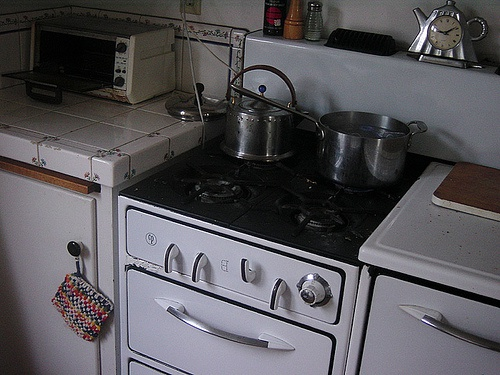Describe the objects in this image and their specific colors. I can see oven in black, darkgray, and gray tones, refrigerator in black and gray tones, microwave in black and gray tones, clock in black, gray, and darkgreen tones, and bottle in black and gray tones in this image. 